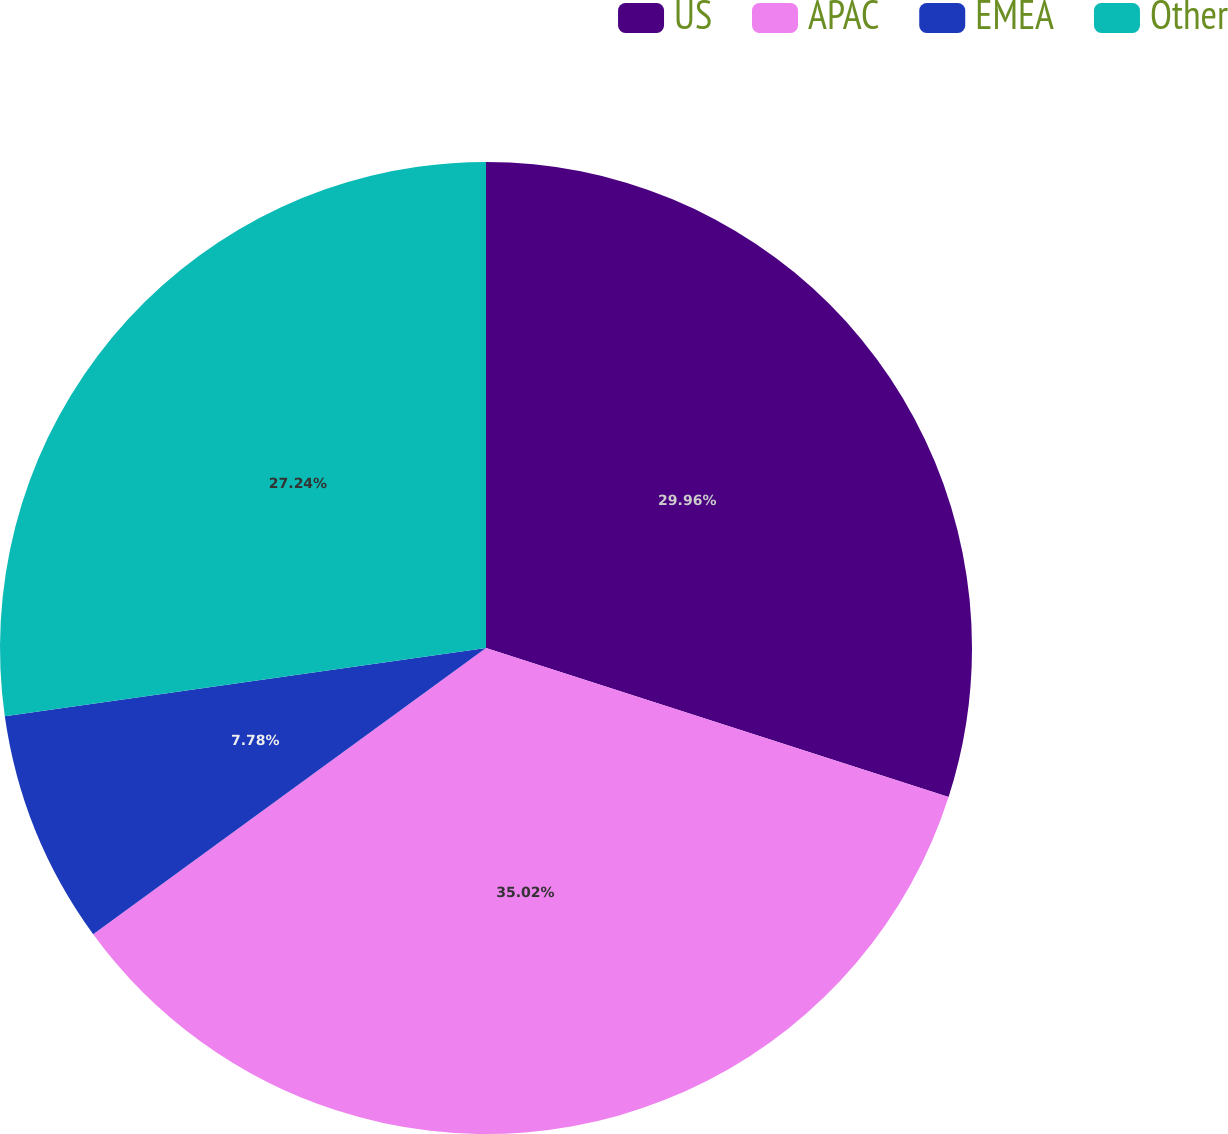Convert chart to OTSL. <chart><loc_0><loc_0><loc_500><loc_500><pie_chart><fcel>US<fcel>APAC<fcel>EMEA<fcel>Other<nl><fcel>29.96%<fcel>35.02%<fcel>7.78%<fcel>27.24%<nl></chart> 